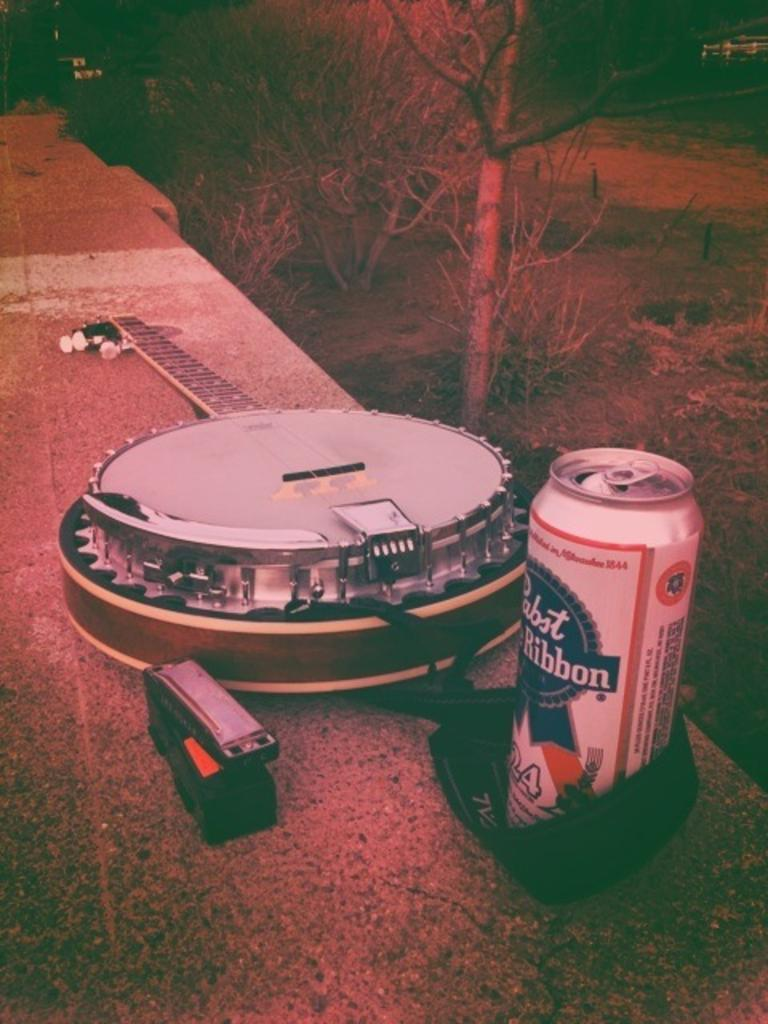<image>
Summarize the visual content of the image. a can that says the word Ribbon on it 